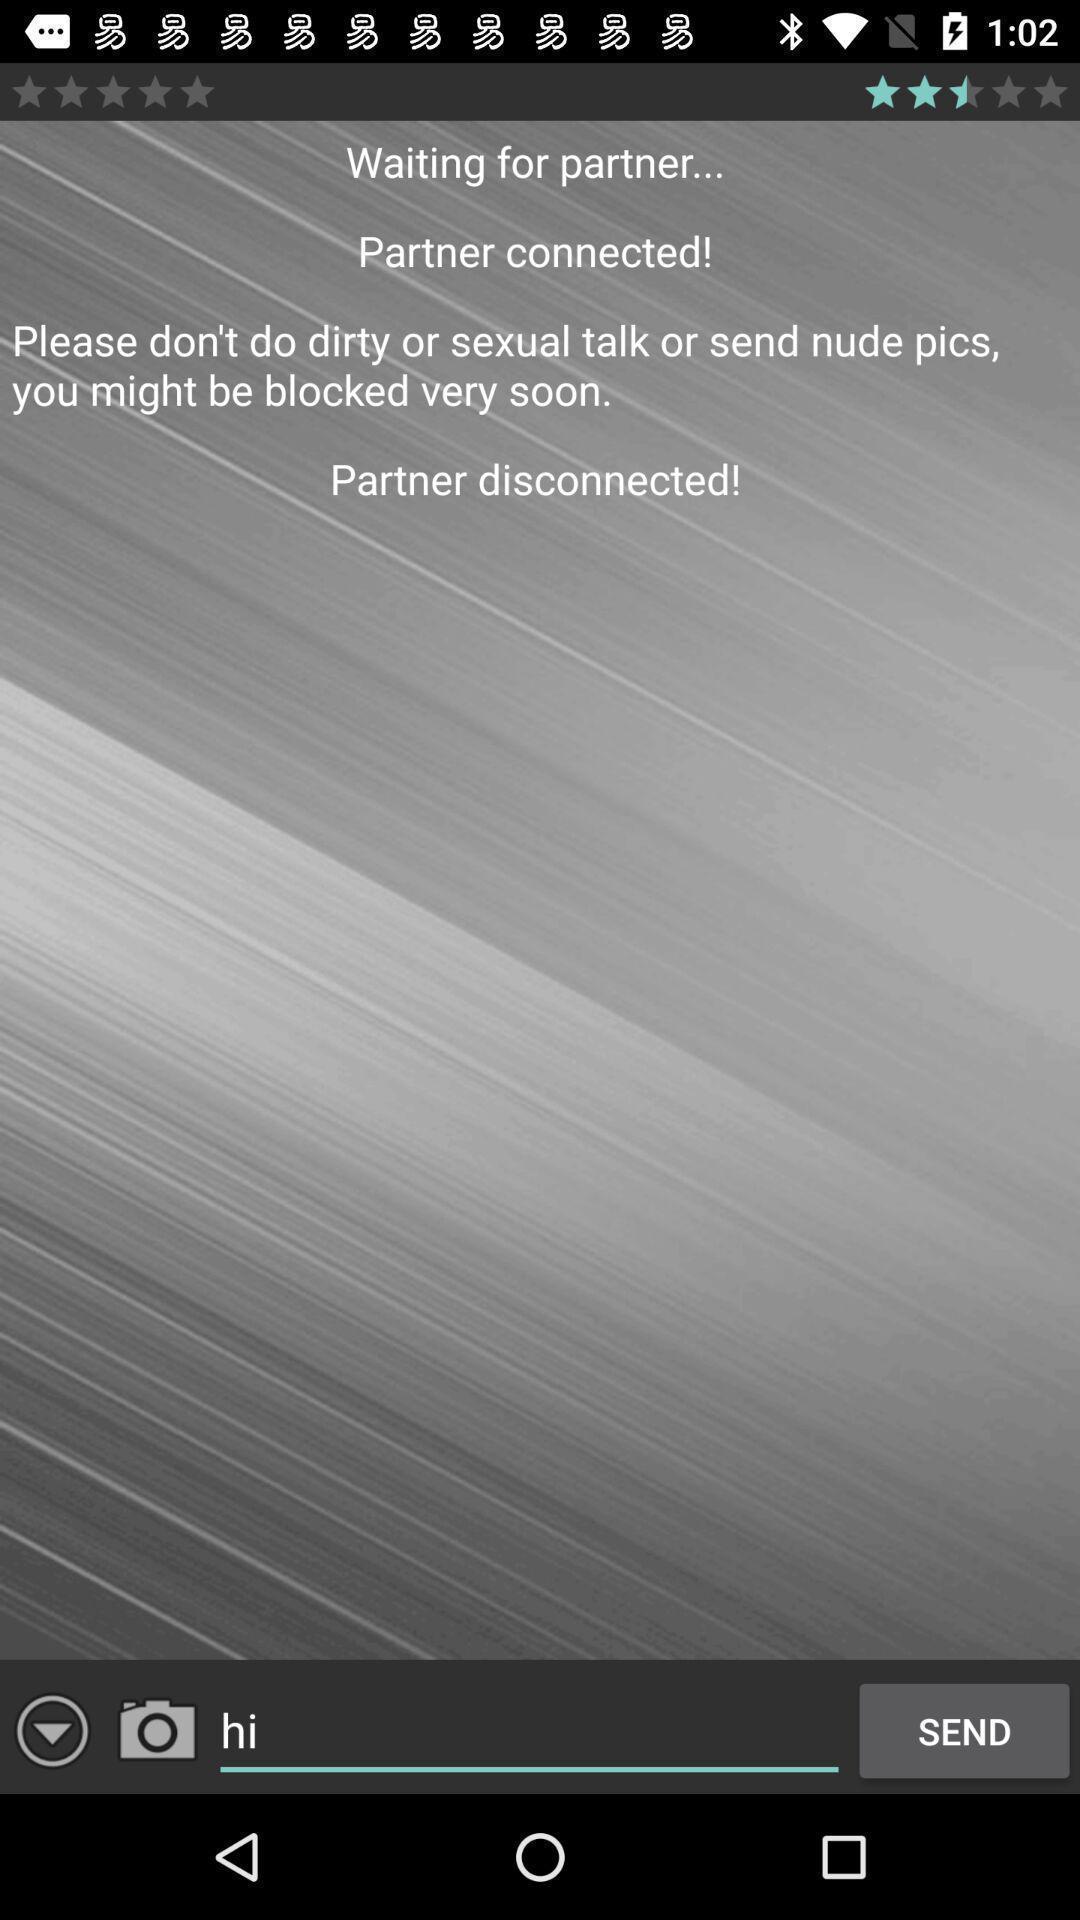Tell me what you see in this picture. Screen shows an online chatting app. 